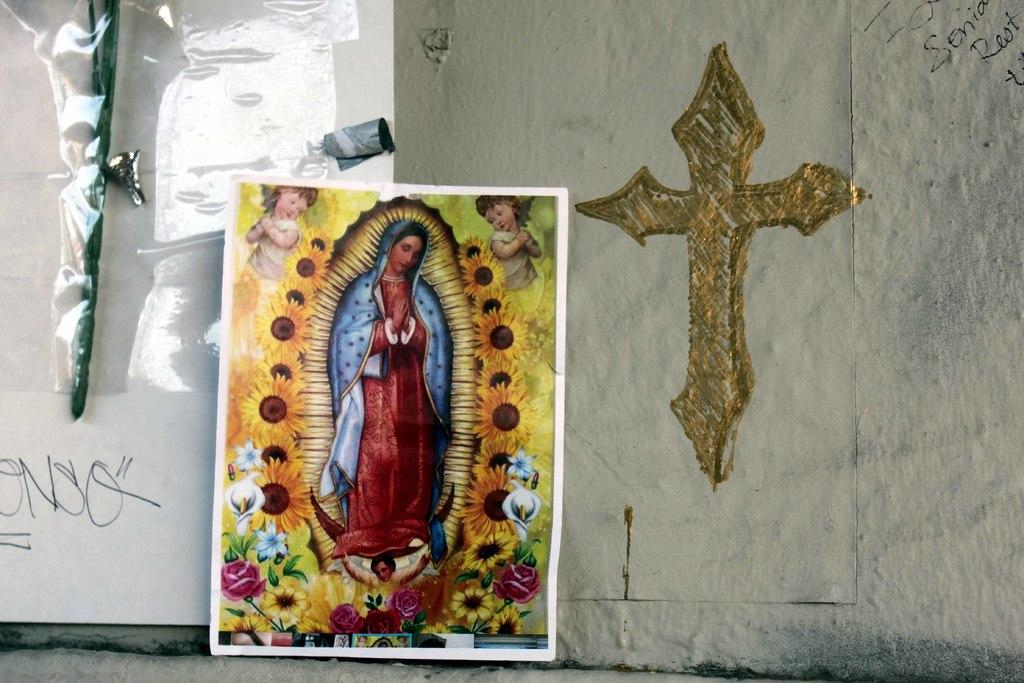<image>
Provide a brief description of the given image. wall with gold cross on it and religious poster against wall and tagged with letters onso 